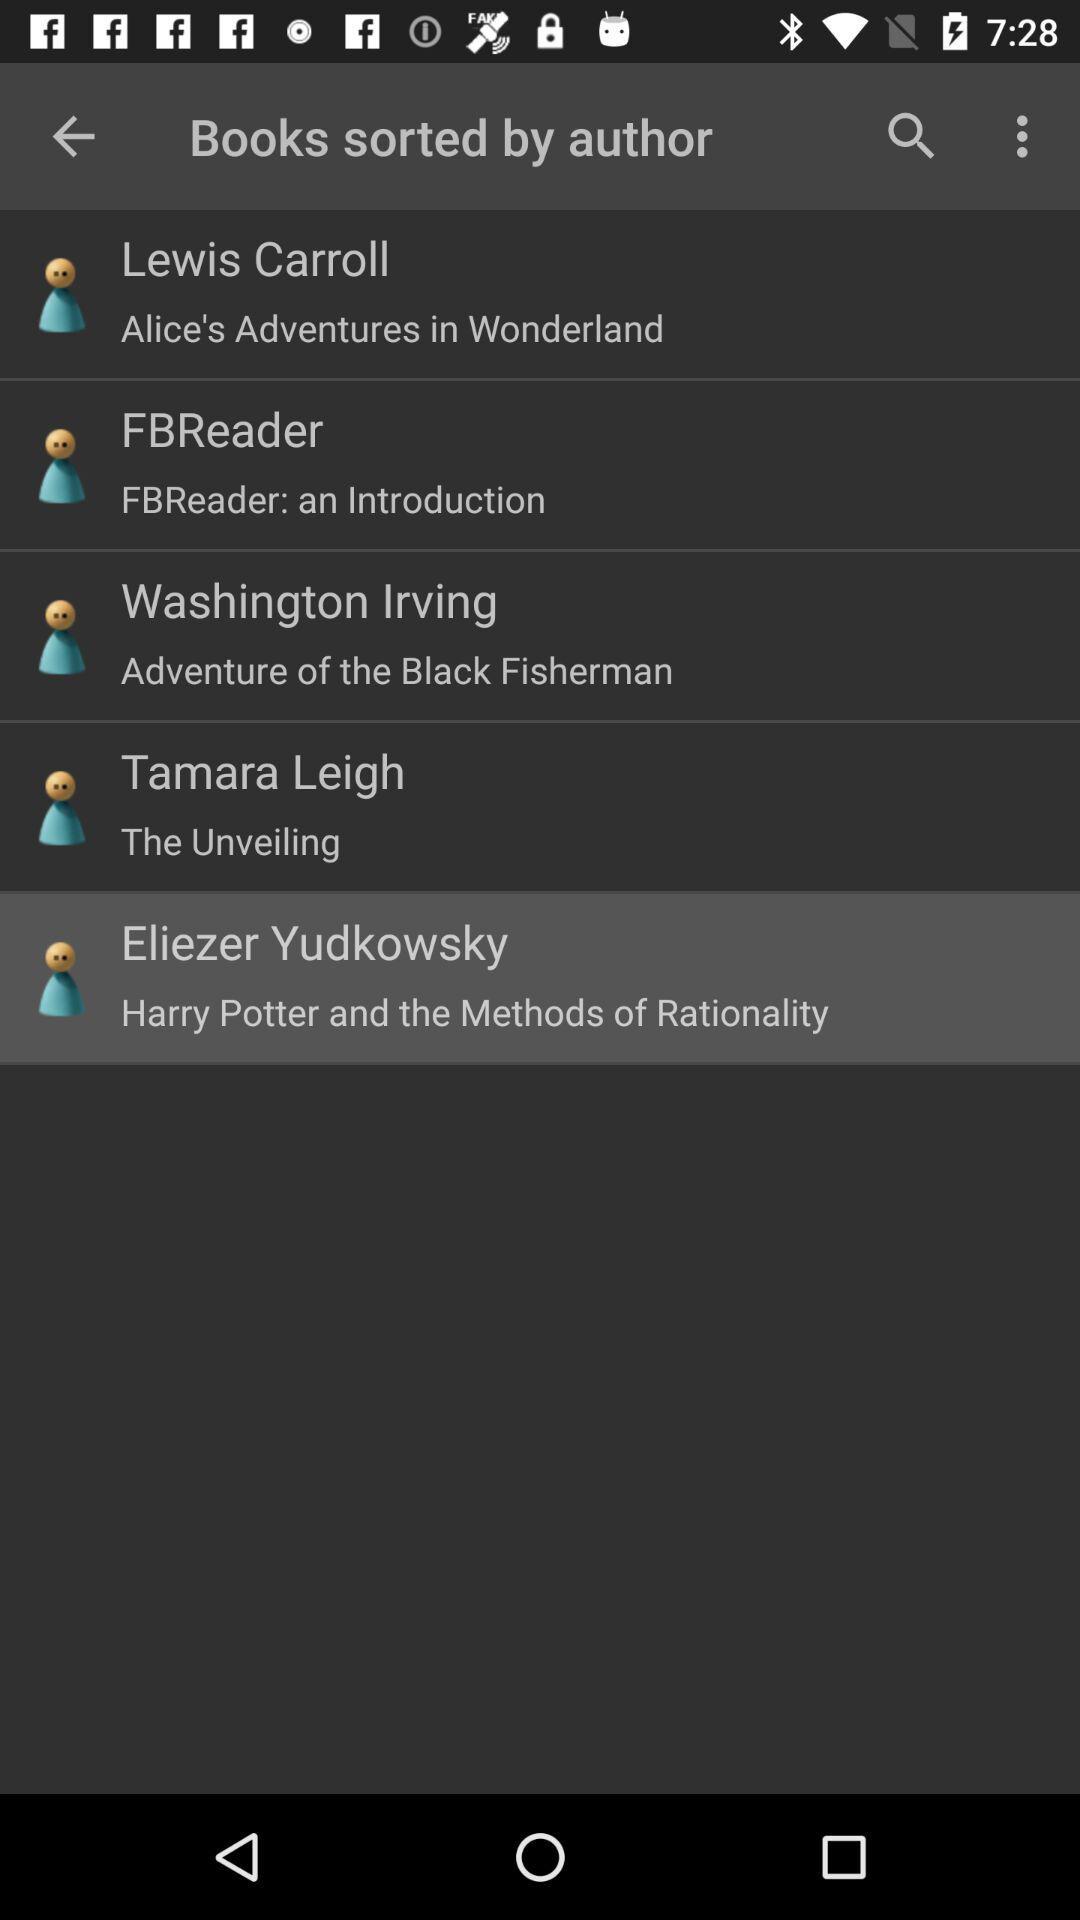Who is the author of "The Unveiling"? The author is Tamara Leigh. 